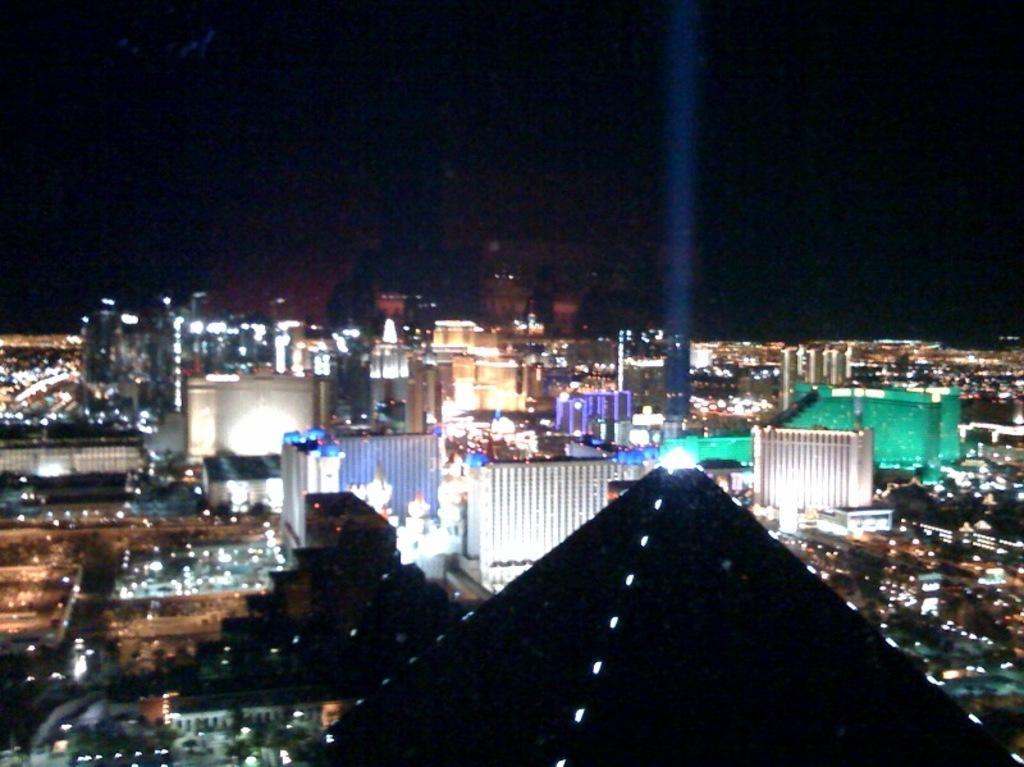Please provide a concise description of this image. In this picture I can see buildings and I can see lights and looks like picture is taken in the dark 